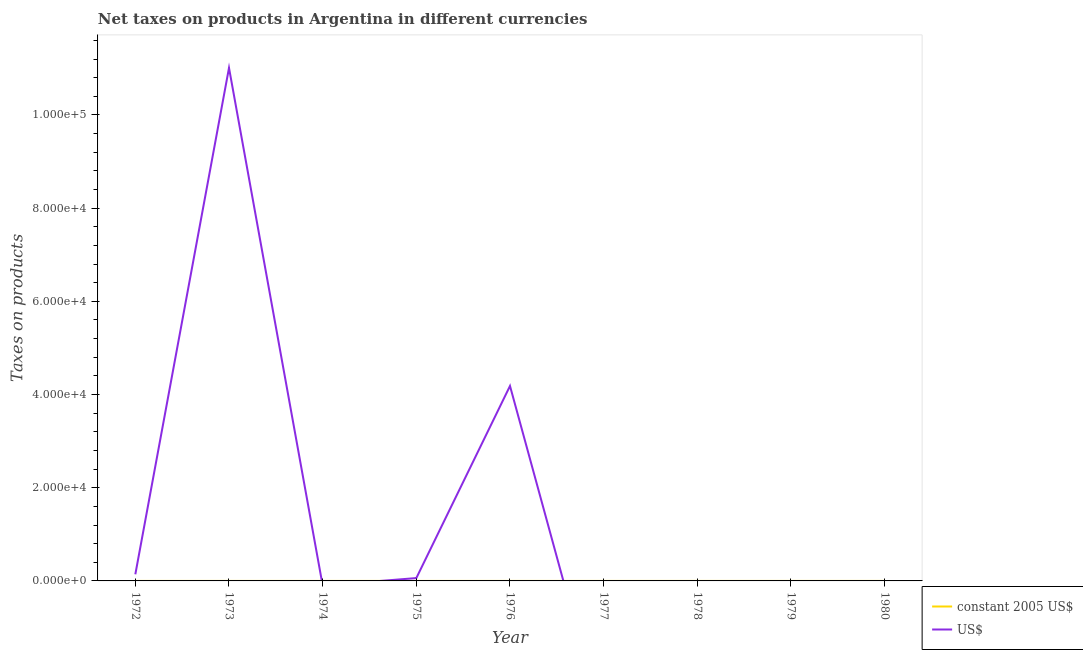How many different coloured lines are there?
Provide a short and direct response. 2. What is the net taxes in constant 2005 us$ in 1972?
Offer a very short reply. 1.136e-7. Across all years, what is the maximum net taxes in us$?
Your answer should be compact. 1.10e+05. Across all years, what is the minimum net taxes in constant 2005 us$?
Your response must be concise. 0. In which year was the net taxes in us$ maximum?
Make the answer very short. 1973. What is the total net taxes in constant 2005 us$ in the graph?
Offer a terse response. 9.39332e-5. What is the difference between the net taxes in constant 2005 us$ in 1973 and that in 1975?
Make the answer very short. 9.6839e-6. What is the difference between the net taxes in constant 2005 us$ in 1975 and the net taxes in us$ in 1972?
Ensure brevity in your answer.  -1420. What is the average net taxes in us$ per year?
Ensure brevity in your answer.  1.71e+04. In the year 1973, what is the difference between the net taxes in us$ and net taxes in constant 2005 us$?
Give a very brief answer. 1.10e+05. What is the ratio of the net taxes in constant 2005 us$ in 1972 to that in 1973?
Your response must be concise. 0.01. Is the net taxes in constant 2005 us$ in 1972 less than that in 1975?
Your answer should be compact. Yes. Is the difference between the net taxes in us$ in 1973 and 1976 greater than the difference between the net taxes in constant 2005 us$ in 1973 and 1976?
Ensure brevity in your answer.  Yes. What is the difference between the highest and the second highest net taxes in us$?
Your response must be concise. 6.83e+04. What is the difference between the highest and the lowest net taxes in constant 2005 us$?
Offer a very short reply. 8.36849e-5. In how many years, is the net taxes in us$ greater than the average net taxes in us$ taken over all years?
Your answer should be compact. 2. Is the net taxes in constant 2005 us$ strictly greater than the net taxes in us$ over the years?
Provide a short and direct response. No. Where does the legend appear in the graph?
Offer a very short reply. Bottom right. What is the title of the graph?
Give a very brief answer. Net taxes on products in Argentina in different currencies. What is the label or title of the X-axis?
Offer a terse response. Year. What is the label or title of the Y-axis?
Your answer should be very brief. Taxes on products. What is the Taxes on products of constant 2005 US$ in 1972?
Provide a succinct answer. 1.136e-7. What is the Taxes on products of US$ in 1972?
Your answer should be compact. 1420. What is the Taxes on products in constant 2005 US$ in 1973?
Make the answer very short. 9.9093e-6. What is the Taxes on products of US$ in 1973?
Give a very brief answer. 1.10e+05. What is the Taxes on products of US$ in 1974?
Offer a terse response. 0. What is the Taxes on products of constant 2005 US$ in 1975?
Give a very brief answer. 2.254e-7. What is the Taxes on products of US$ in 1975?
Ensure brevity in your answer.  609.19. What is the Taxes on products in constant 2005 US$ in 1976?
Keep it short and to the point. 8.36849e-5. What is the Taxes on products of US$ in 1976?
Keep it short and to the point. 4.18e+04. What is the Taxes on products in US$ in 1977?
Your answer should be very brief. 0. What is the Taxes on products in constant 2005 US$ in 1978?
Offer a very short reply. 0. What is the Taxes on products of US$ in 1979?
Offer a very short reply. 0. What is the Taxes on products in constant 2005 US$ in 1980?
Make the answer very short. 0. What is the Taxes on products in US$ in 1980?
Your answer should be compact. 0. Across all years, what is the maximum Taxes on products in constant 2005 US$?
Provide a succinct answer. 8.36849e-5. Across all years, what is the maximum Taxes on products of US$?
Give a very brief answer. 1.10e+05. Across all years, what is the minimum Taxes on products of constant 2005 US$?
Your answer should be very brief. 0. Across all years, what is the minimum Taxes on products of US$?
Keep it short and to the point. 0. What is the total Taxes on products of US$ in the graph?
Ensure brevity in your answer.  1.54e+05. What is the difference between the Taxes on products in constant 2005 US$ in 1972 and that in 1973?
Provide a short and direct response. -0. What is the difference between the Taxes on products of US$ in 1972 and that in 1973?
Your answer should be compact. -1.09e+05. What is the difference between the Taxes on products of US$ in 1972 and that in 1975?
Provide a succinct answer. 810.81. What is the difference between the Taxes on products in constant 2005 US$ in 1972 and that in 1976?
Give a very brief answer. -0. What is the difference between the Taxes on products of US$ in 1972 and that in 1976?
Keep it short and to the point. -4.04e+04. What is the difference between the Taxes on products of constant 2005 US$ in 1973 and that in 1975?
Keep it short and to the point. 0. What is the difference between the Taxes on products of US$ in 1973 and that in 1975?
Offer a terse response. 1.09e+05. What is the difference between the Taxes on products of constant 2005 US$ in 1973 and that in 1976?
Your answer should be very brief. -0. What is the difference between the Taxes on products of US$ in 1973 and that in 1976?
Offer a terse response. 6.83e+04. What is the difference between the Taxes on products in constant 2005 US$ in 1975 and that in 1976?
Your answer should be compact. -0. What is the difference between the Taxes on products of US$ in 1975 and that in 1976?
Offer a very short reply. -4.12e+04. What is the difference between the Taxes on products of constant 2005 US$ in 1972 and the Taxes on products of US$ in 1973?
Your answer should be compact. -1.10e+05. What is the difference between the Taxes on products in constant 2005 US$ in 1972 and the Taxes on products in US$ in 1975?
Ensure brevity in your answer.  -609.19. What is the difference between the Taxes on products in constant 2005 US$ in 1972 and the Taxes on products in US$ in 1976?
Give a very brief answer. -4.18e+04. What is the difference between the Taxes on products of constant 2005 US$ in 1973 and the Taxes on products of US$ in 1975?
Offer a very short reply. -609.19. What is the difference between the Taxes on products of constant 2005 US$ in 1973 and the Taxes on products of US$ in 1976?
Keep it short and to the point. -4.18e+04. What is the difference between the Taxes on products of constant 2005 US$ in 1975 and the Taxes on products of US$ in 1976?
Ensure brevity in your answer.  -4.18e+04. What is the average Taxes on products of US$ per year?
Give a very brief answer. 1.71e+04. In the year 1972, what is the difference between the Taxes on products in constant 2005 US$ and Taxes on products in US$?
Your answer should be very brief. -1420. In the year 1973, what is the difference between the Taxes on products of constant 2005 US$ and Taxes on products of US$?
Your answer should be very brief. -1.10e+05. In the year 1975, what is the difference between the Taxes on products in constant 2005 US$ and Taxes on products in US$?
Offer a very short reply. -609.19. In the year 1976, what is the difference between the Taxes on products in constant 2005 US$ and Taxes on products in US$?
Ensure brevity in your answer.  -4.18e+04. What is the ratio of the Taxes on products in constant 2005 US$ in 1972 to that in 1973?
Ensure brevity in your answer.  0.01. What is the ratio of the Taxes on products in US$ in 1972 to that in 1973?
Your response must be concise. 0.01. What is the ratio of the Taxes on products of constant 2005 US$ in 1972 to that in 1975?
Your answer should be compact. 0.5. What is the ratio of the Taxes on products in US$ in 1972 to that in 1975?
Offer a very short reply. 2.33. What is the ratio of the Taxes on products in constant 2005 US$ in 1972 to that in 1976?
Give a very brief answer. 0. What is the ratio of the Taxes on products in US$ in 1972 to that in 1976?
Make the answer very short. 0.03. What is the ratio of the Taxes on products of constant 2005 US$ in 1973 to that in 1975?
Offer a very short reply. 43.96. What is the ratio of the Taxes on products of US$ in 1973 to that in 1975?
Offer a terse response. 180.74. What is the ratio of the Taxes on products in constant 2005 US$ in 1973 to that in 1976?
Give a very brief answer. 0.12. What is the ratio of the Taxes on products of US$ in 1973 to that in 1976?
Your answer should be very brief. 2.63. What is the ratio of the Taxes on products of constant 2005 US$ in 1975 to that in 1976?
Make the answer very short. 0. What is the ratio of the Taxes on products in US$ in 1975 to that in 1976?
Your answer should be very brief. 0.01. What is the difference between the highest and the second highest Taxes on products in constant 2005 US$?
Make the answer very short. 0. What is the difference between the highest and the second highest Taxes on products of US$?
Give a very brief answer. 6.83e+04. What is the difference between the highest and the lowest Taxes on products of US$?
Ensure brevity in your answer.  1.10e+05. 